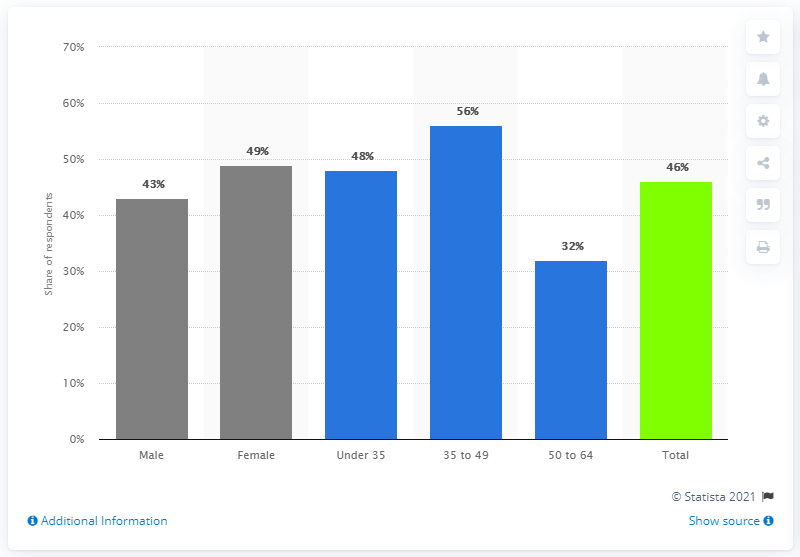Point out several critical features in this image. The age range most likely to report using a weather app is 35 to 49 years old. 